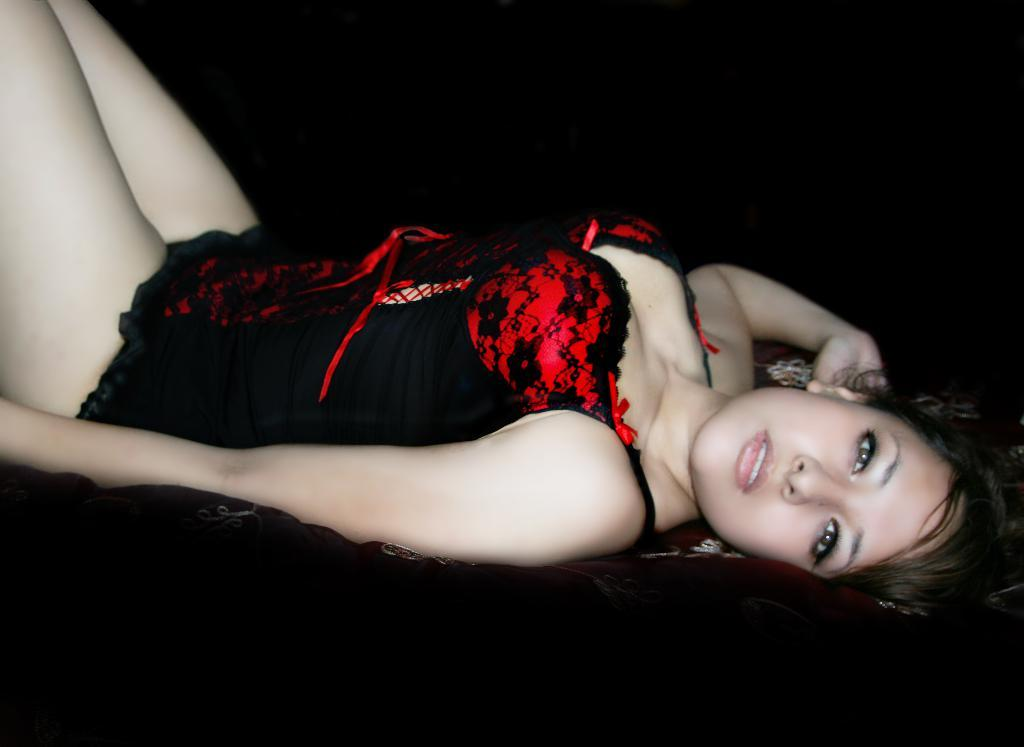Who is the main subject in the image? There is a woman in the image. What is the woman doing in the image? The woman is laying on a bed. What is the woman wearing in the image? The woman is wearing a black and red colored dress. What type of bead is the woman using to hear the conversation in the image? There is no bead present in the image, nor is there any indication of a conversation taking place. 